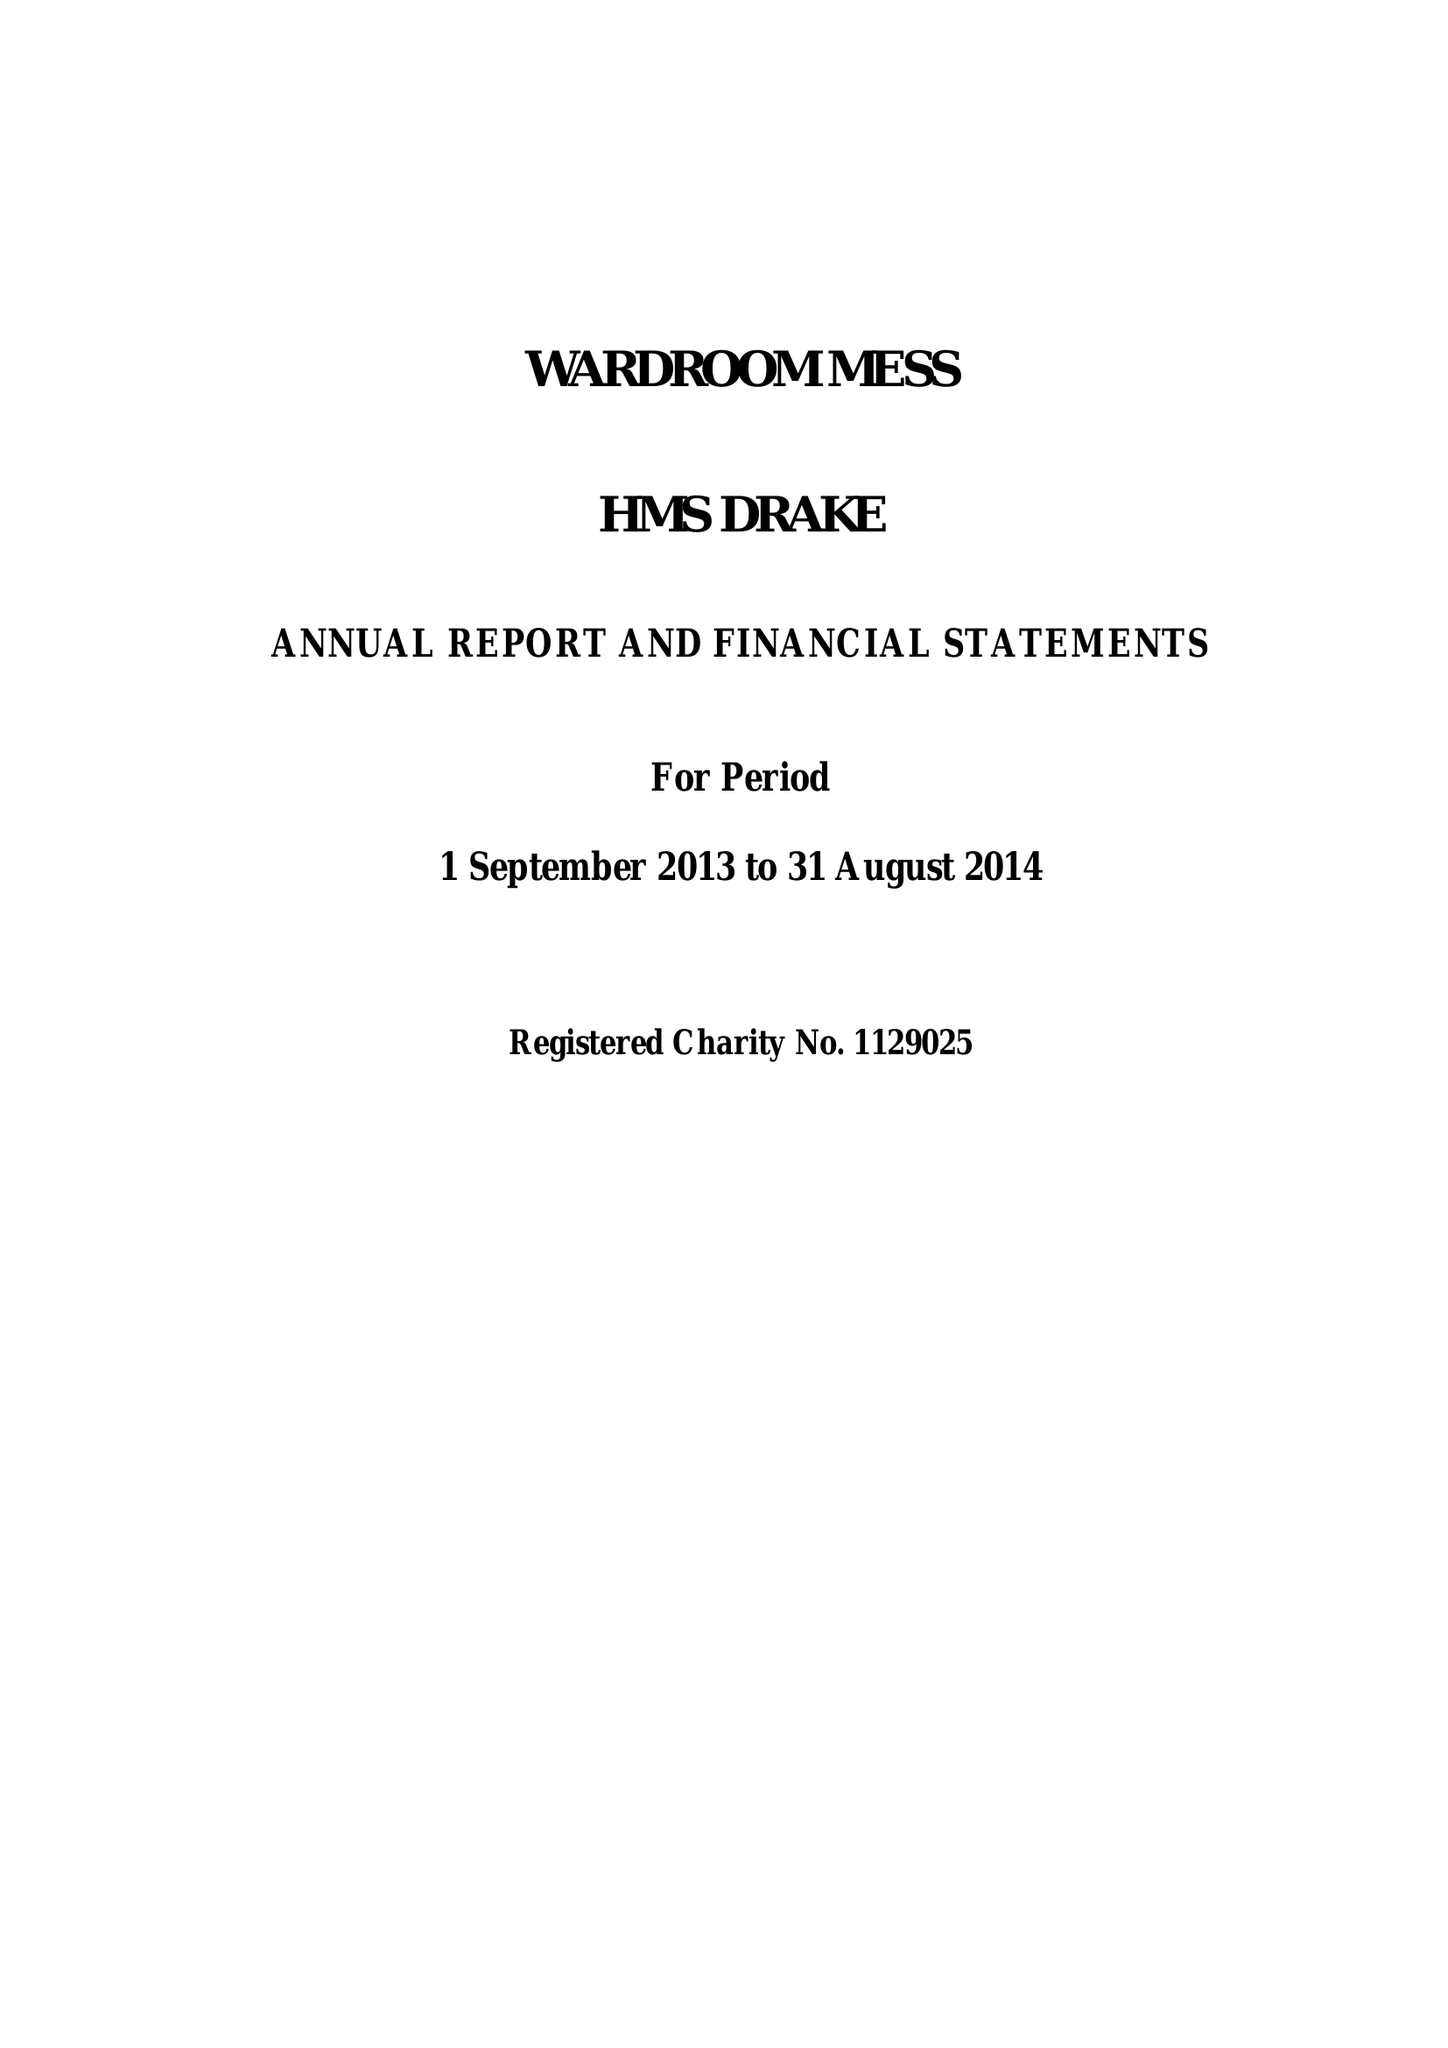What is the value for the income_annually_in_british_pounds?
Answer the question using a single word or phrase. 166861.00 